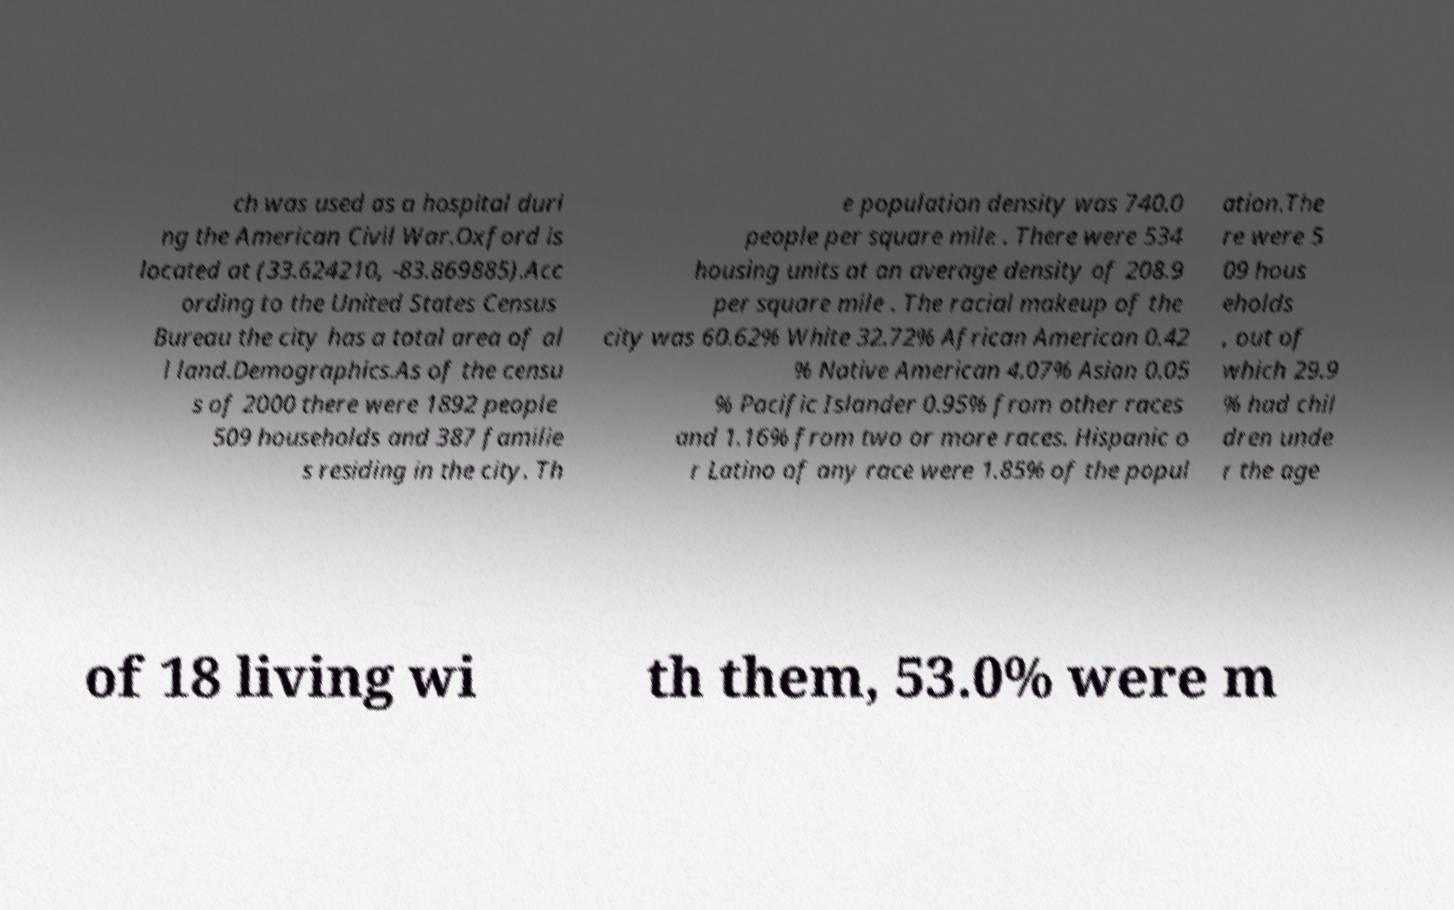Please read and relay the text visible in this image. What does it say? ch was used as a hospital duri ng the American Civil War.Oxford is located at (33.624210, -83.869885).Acc ording to the United States Census Bureau the city has a total area of al l land.Demographics.As of the censu s of 2000 there were 1892 people 509 households and 387 familie s residing in the city. Th e population density was 740.0 people per square mile . There were 534 housing units at an average density of 208.9 per square mile . The racial makeup of the city was 60.62% White 32.72% African American 0.42 % Native American 4.07% Asian 0.05 % Pacific Islander 0.95% from other races and 1.16% from two or more races. Hispanic o r Latino of any race were 1.85% of the popul ation.The re were 5 09 hous eholds , out of which 29.9 % had chil dren unde r the age of 18 living wi th them, 53.0% were m 